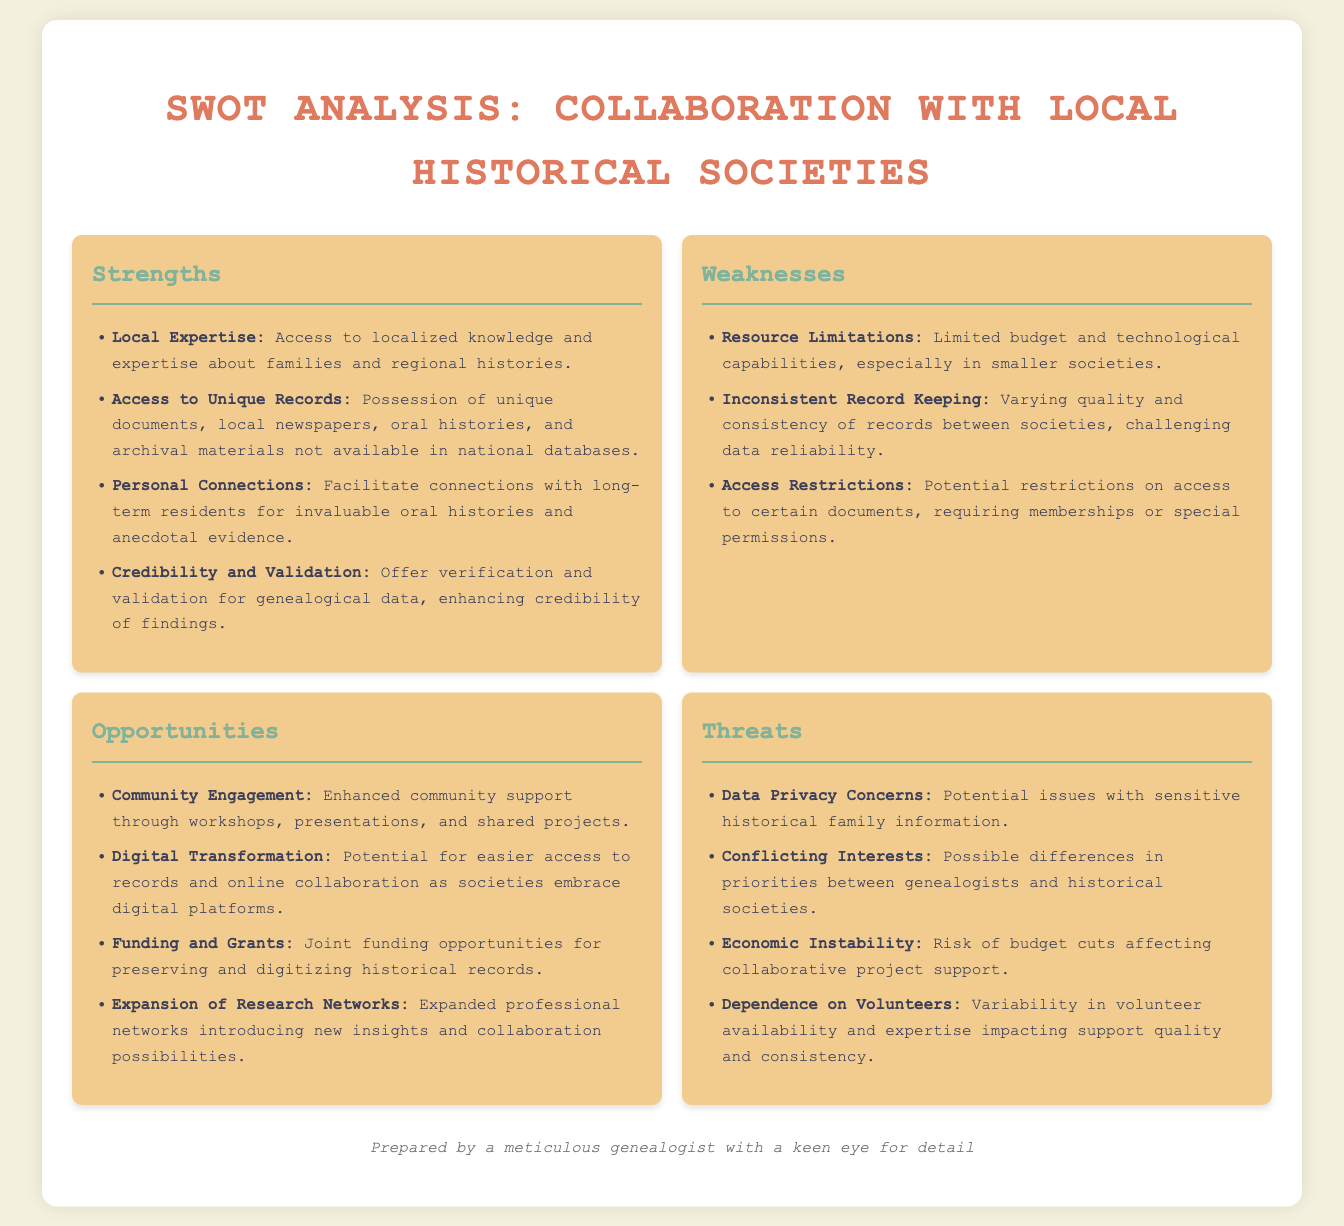what is the title of the document? The title is mentioned prominently at the top of the document, indicating the subject of the analysis.
Answer: SWOT Analysis: Collaboration with Local Historical Societies how many strengths are listed? The strengths section lists a total of four specific items, showing the advantages of the collaboration.
Answer: 4 which weakness relates to budget issues? The weakness specifically mentions financial constraints faced by smaller societies, indicating limited resources.
Answer: Resource Limitations what opportunity involves digital access? This opportunity focuses on the potential for better accessibility to records through online platforms as societies modernize.
Answer: Digital Transformation what is a potential threat regarding historical information? The document notes a concern regarding the sensitivity of historical family data and its implications.
Answer: Data Privacy Concerns which strength emphasizes local knowledge? The strength that highlights the importance of localized expertise regarding families and regional histories.
Answer: Local Expertise what is the main focus of the 'Opportunities' section? The main focus is to present prospects for enhancing community involvement and support for genealogical research.
Answer: Community Engagement how many threats are identified in the analysis? The threats section outlines four specific risks that may impact collaboration with historical societies.
Answer: 4 what is a challenge noted in the weaknesses section? The challenge specifically points to varied quality and reliability issues of records across different societies.
Answer: Inconsistent Record Keeping 